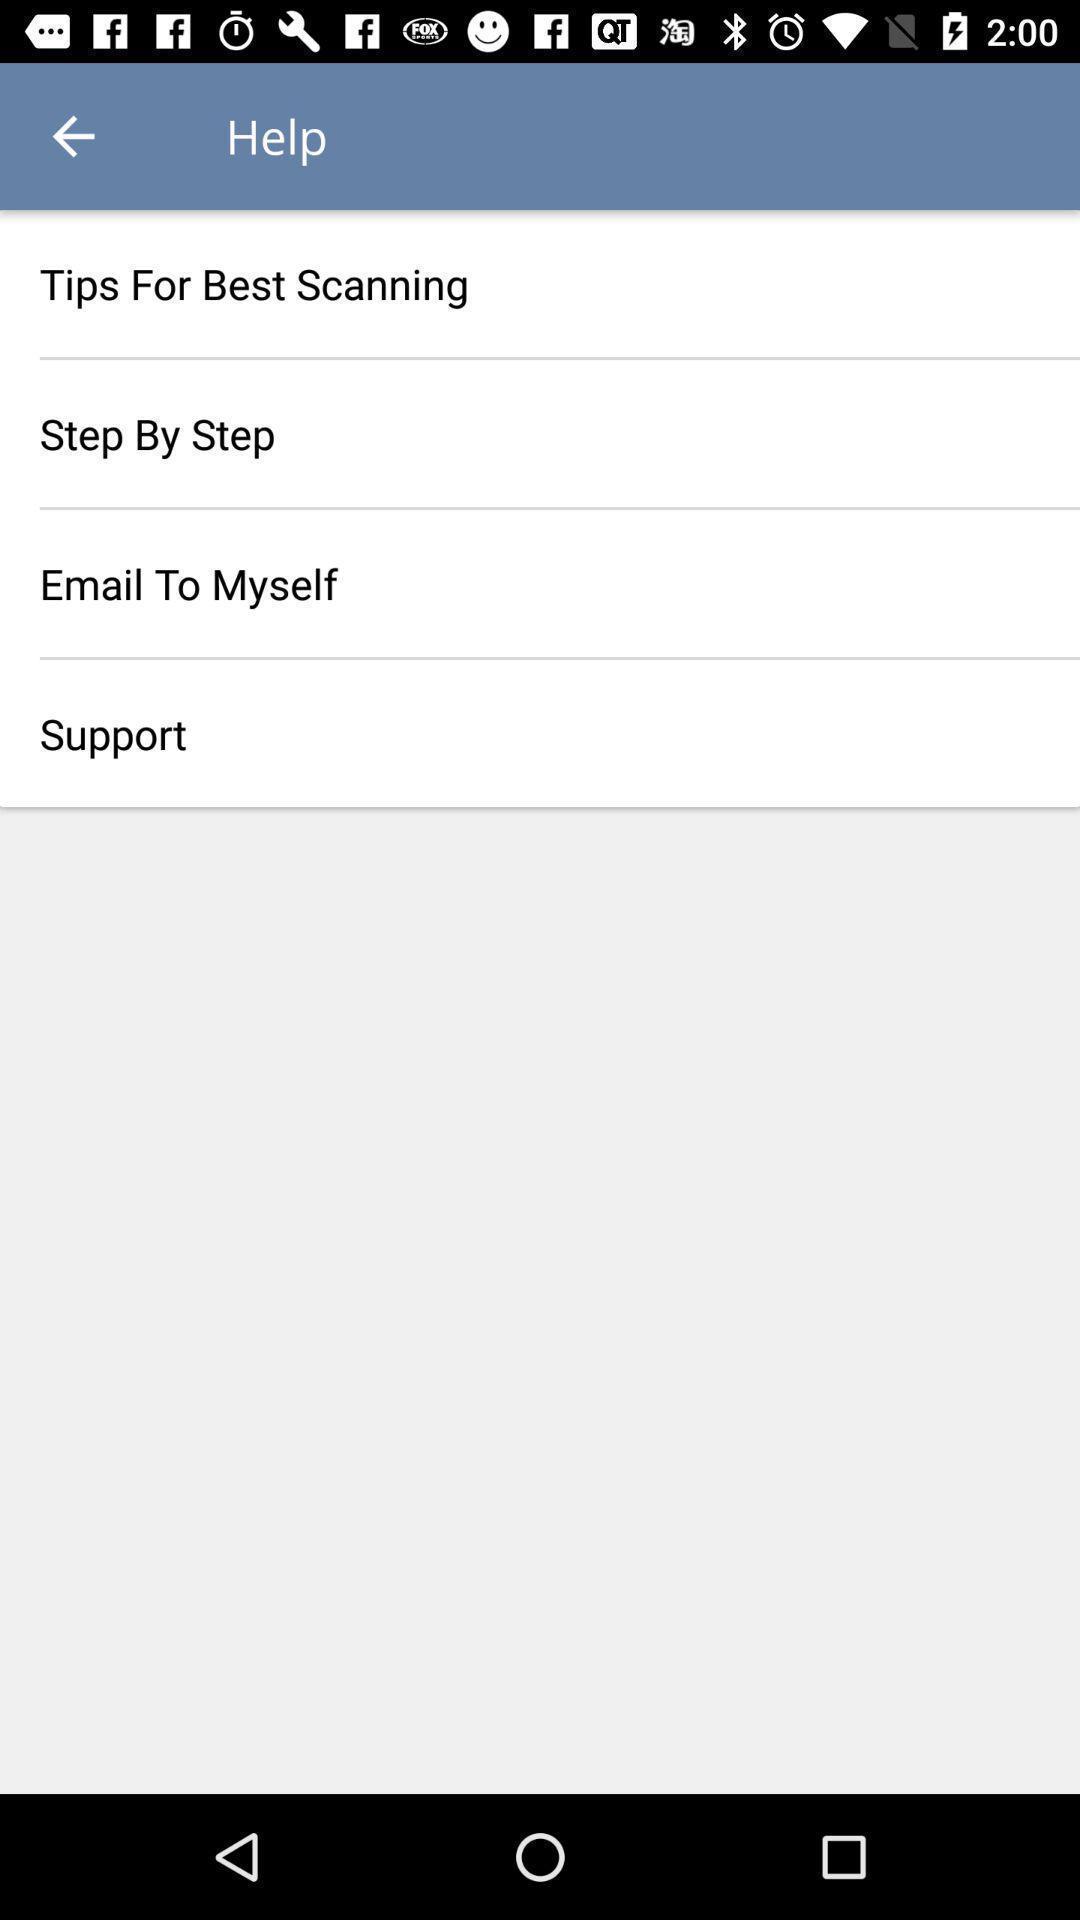Tell me about the visual elements in this screen capture. Screen shows help list in an scanner app. 